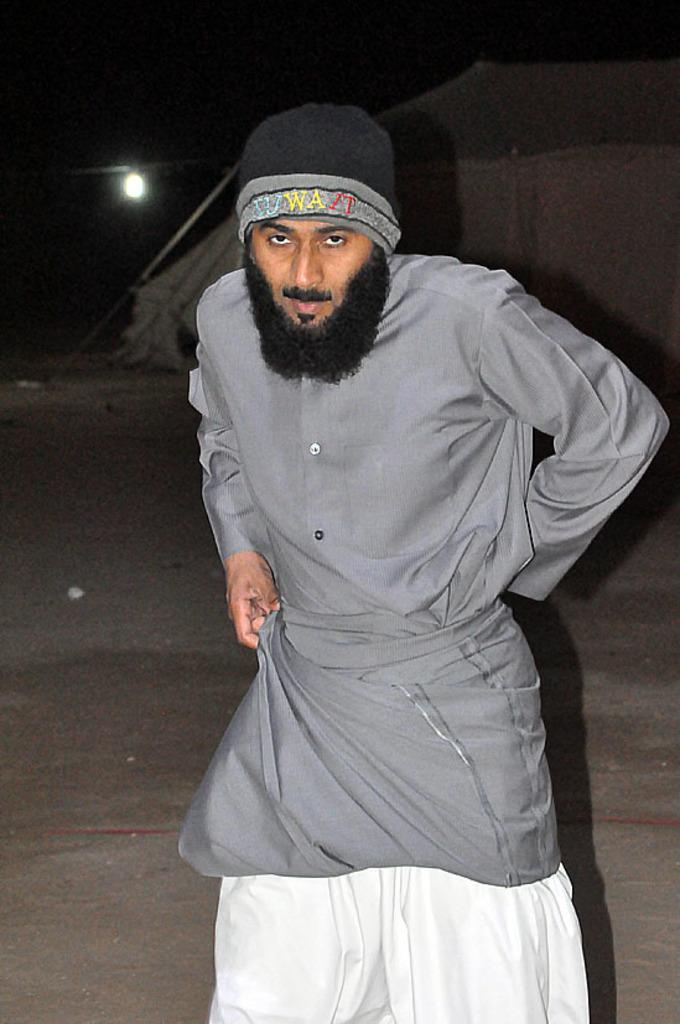Can you describe this image briefly? In this image I can see person standing, wearing a cap, grey shirt and he has beard. There is a light at the back. 